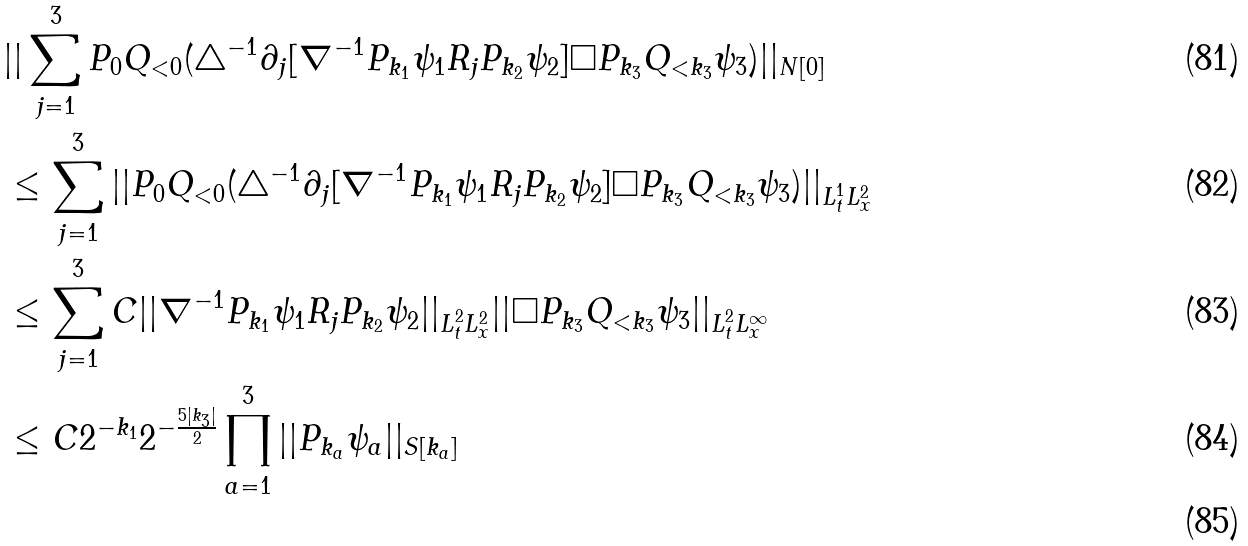<formula> <loc_0><loc_0><loc_500><loc_500>& | | \sum _ { j = 1 } ^ { 3 } P _ { 0 } Q _ { < 0 } ( \triangle ^ { - 1 } \partial _ { j } [ \nabla ^ { - 1 } P _ { k _ { 1 } } \psi _ { 1 } R _ { j } P _ { k _ { 2 } } \psi _ { 2 } ] \Box P _ { k _ { 3 } } Q _ { < k _ { 3 } } \psi _ { 3 } ) | | _ { N [ 0 ] } \\ & \leq \sum _ { j = 1 } ^ { 3 } | | P _ { 0 } Q _ { < 0 } ( \triangle ^ { - 1 } \partial _ { j } [ \nabla ^ { - 1 } P _ { k _ { 1 } } \psi _ { 1 } R _ { j } P _ { k _ { 2 } } \psi _ { 2 } ] \Box P _ { k _ { 3 } } Q _ { < k _ { 3 } } \psi _ { 3 } ) | | _ { L _ { t } ^ { 1 } L _ { x } ^ { 2 } } \\ & \leq \sum _ { j = 1 } ^ { 3 } C | | \nabla ^ { - 1 } P _ { k _ { 1 } } \psi _ { 1 } R _ { j } P _ { k _ { 2 } } \psi _ { 2 } | | _ { L _ { t } ^ { 2 } L _ { x } ^ { 2 } } | | \Box P _ { k _ { 3 } } Q _ { < k _ { 3 } } \psi _ { 3 } | | _ { L _ { t } ^ { 2 } L _ { x } ^ { \infty } } \\ & \leq C 2 ^ { - k _ { 1 } } 2 ^ { - \frac { 5 | k _ { 3 } | } { 2 } } \prod _ { a = 1 } ^ { 3 } | | P _ { k _ { a } } \psi _ { a } | | _ { S [ k _ { a } ] } \\</formula> 